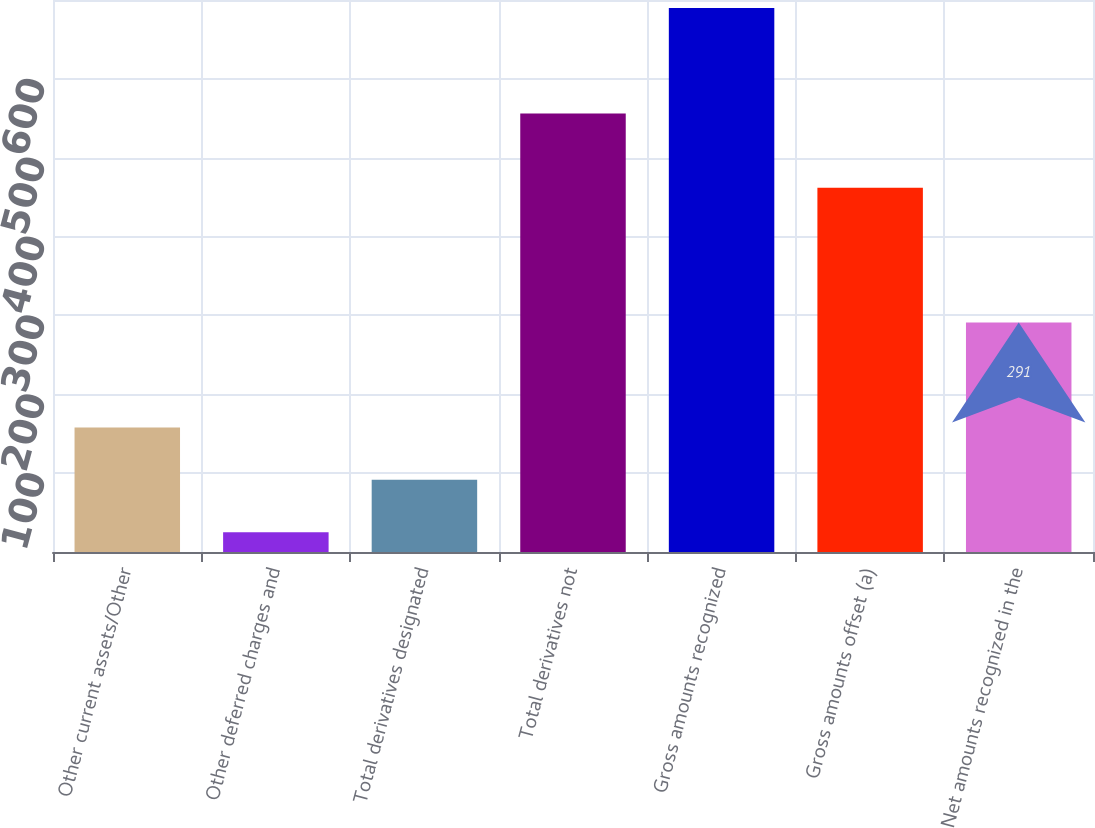<chart> <loc_0><loc_0><loc_500><loc_500><bar_chart><fcel>Other current assets/Other<fcel>Other deferred charges and<fcel>Total derivatives designated<fcel>Total derivatives not<fcel>Gross amounts recognized<fcel>Gross amounts offset (a)<fcel>Net amounts recognized in the<nl><fcel>158<fcel>25<fcel>91.5<fcel>556<fcel>690<fcel>462<fcel>291<nl></chart> 